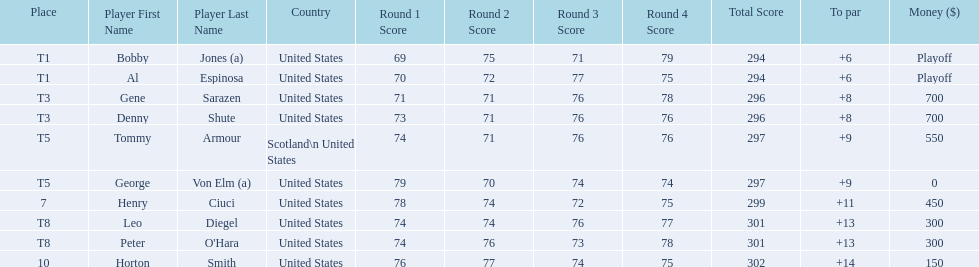What was al espinosa's total stroke count at the final of the 1929 us open? 294. Parse the table in full. {'header': ['Place', 'Player First Name', 'Player Last Name', 'Country', 'Round 1 Score', 'Round 2 Score', 'Round 3 Score', 'Round 4 Score', 'Total Score', 'To par', 'Money ($)'], 'rows': [['T1', 'Bobby', 'Jones (a)', 'United States', '69', '75', '71', '79', '294', '+6', 'Playoff'], ['T1', 'Al', 'Espinosa', 'United States', '70', '72', '77', '75', '294', '+6', 'Playoff'], ['T3', 'Gene', 'Sarazen', 'United States', '71', '71', '76', '78', '296', '+8', '700'], ['T3', 'Denny', 'Shute', 'United States', '73', '71', '76', '76', '296', '+8', '700'], ['T5', 'Tommy', 'Armour', 'Scotland\\n\xa0United States', '74', '71', '76', '76', '297', '+9', '550'], ['T5', 'George', 'Von Elm (a)', 'United States', '79', '70', '74', '74', '297', '+9', '0'], ['7', 'Henry', 'Ciuci', 'United States', '78', '74', '72', '75', '299', '+11', '450'], ['T8', 'Leo', 'Diegel', 'United States', '74', '74', '76', '77', '301', '+13', '300'], ['T8', 'Peter', "O'Hara", 'United States', '74', '76', '73', '78', '301', '+13', '300'], ['10', 'Horton', 'Smith', 'United States', '76', '77', '74', '75', '302', '+14', '150']]} 